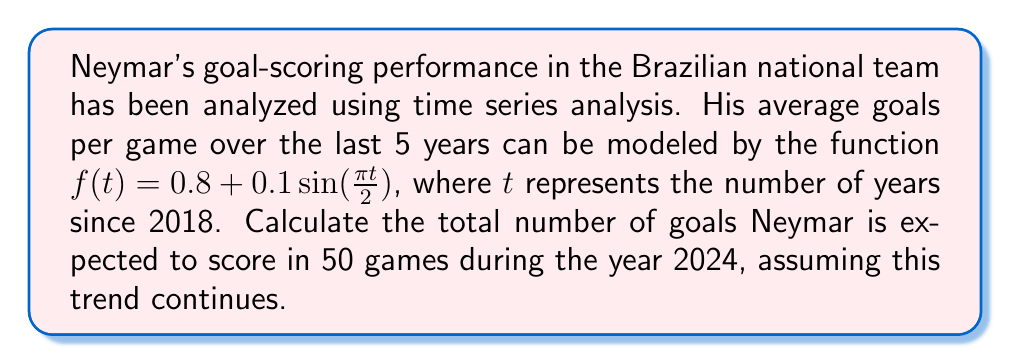Could you help me with this problem? To solve this problem, we'll follow these steps:

1) First, we need to determine the value of $t$ for the year 2024:
   2024 is 6 years after 2018, so $t = 6$.

2) Now, we can calculate the average goals per game for 2024:
   $f(6) = 0.8 + 0.1\sin(\frac{\pi \cdot 6}{2})$
   $= 0.8 + 0.1\sin(3\pi)$
   $= 0.8 + 0.1 \cdot 0$
   $= 0.8$

3) This means Neymar is expected to score an average of 0.8 goals per game in 2024.

4) To find the total number of goals in 50 games, we multiply:
   $50 \cdot 0.8 = 40$

Therefore, Neymar is expected to score 40 goals in 50 games during 2024.
Answer: 40 goals 